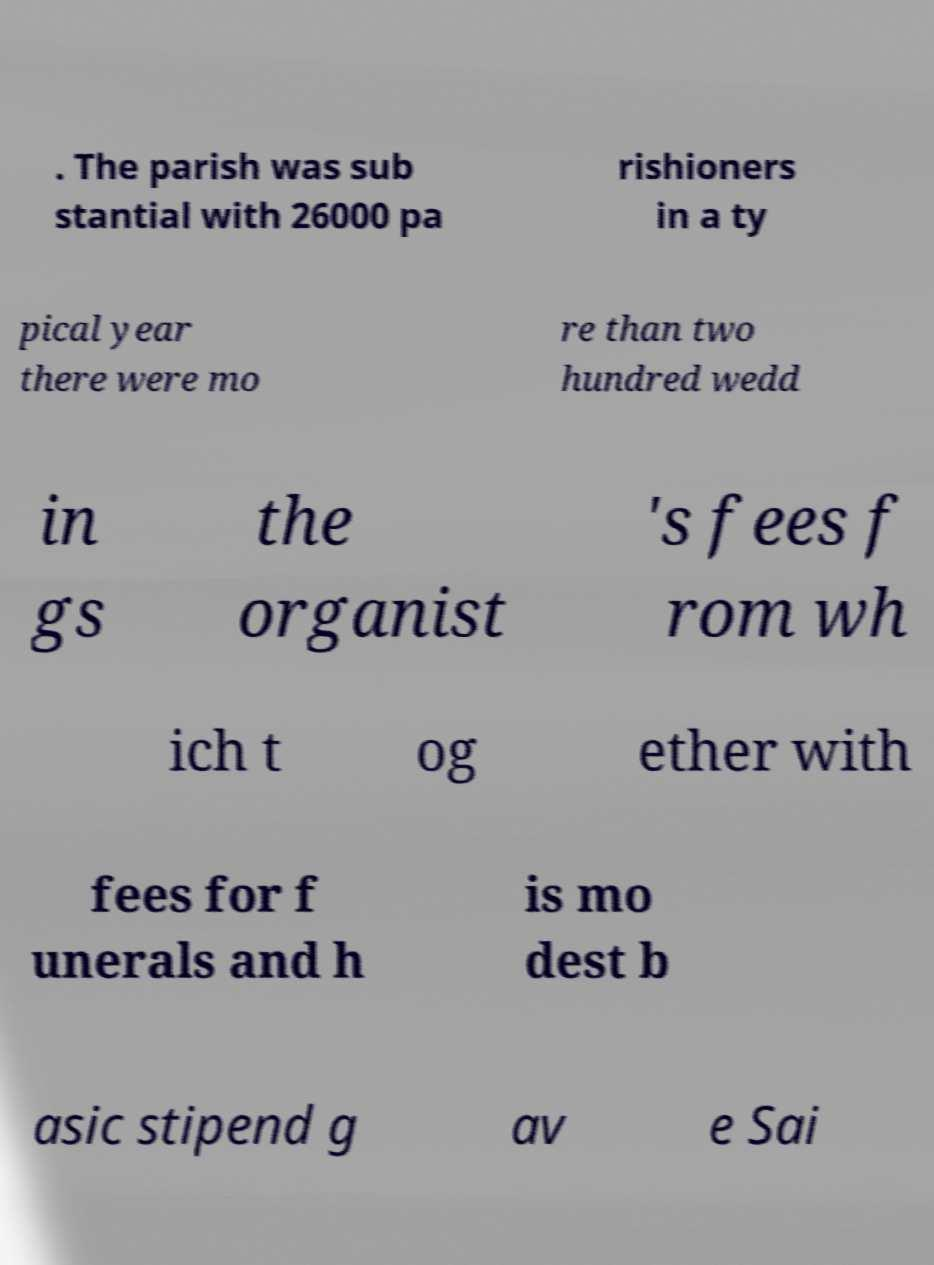What messages or text are displayed in this image? I need them in a readable, typed format. . The parish was sub stantial with 26000 pa rishioners in a ty pical year there were mo re than two hundred wedd in gs the organist 's fees f rom wh ich t og ether with fees for f unerals and h is mo dest b asic stipend g av e Sai 